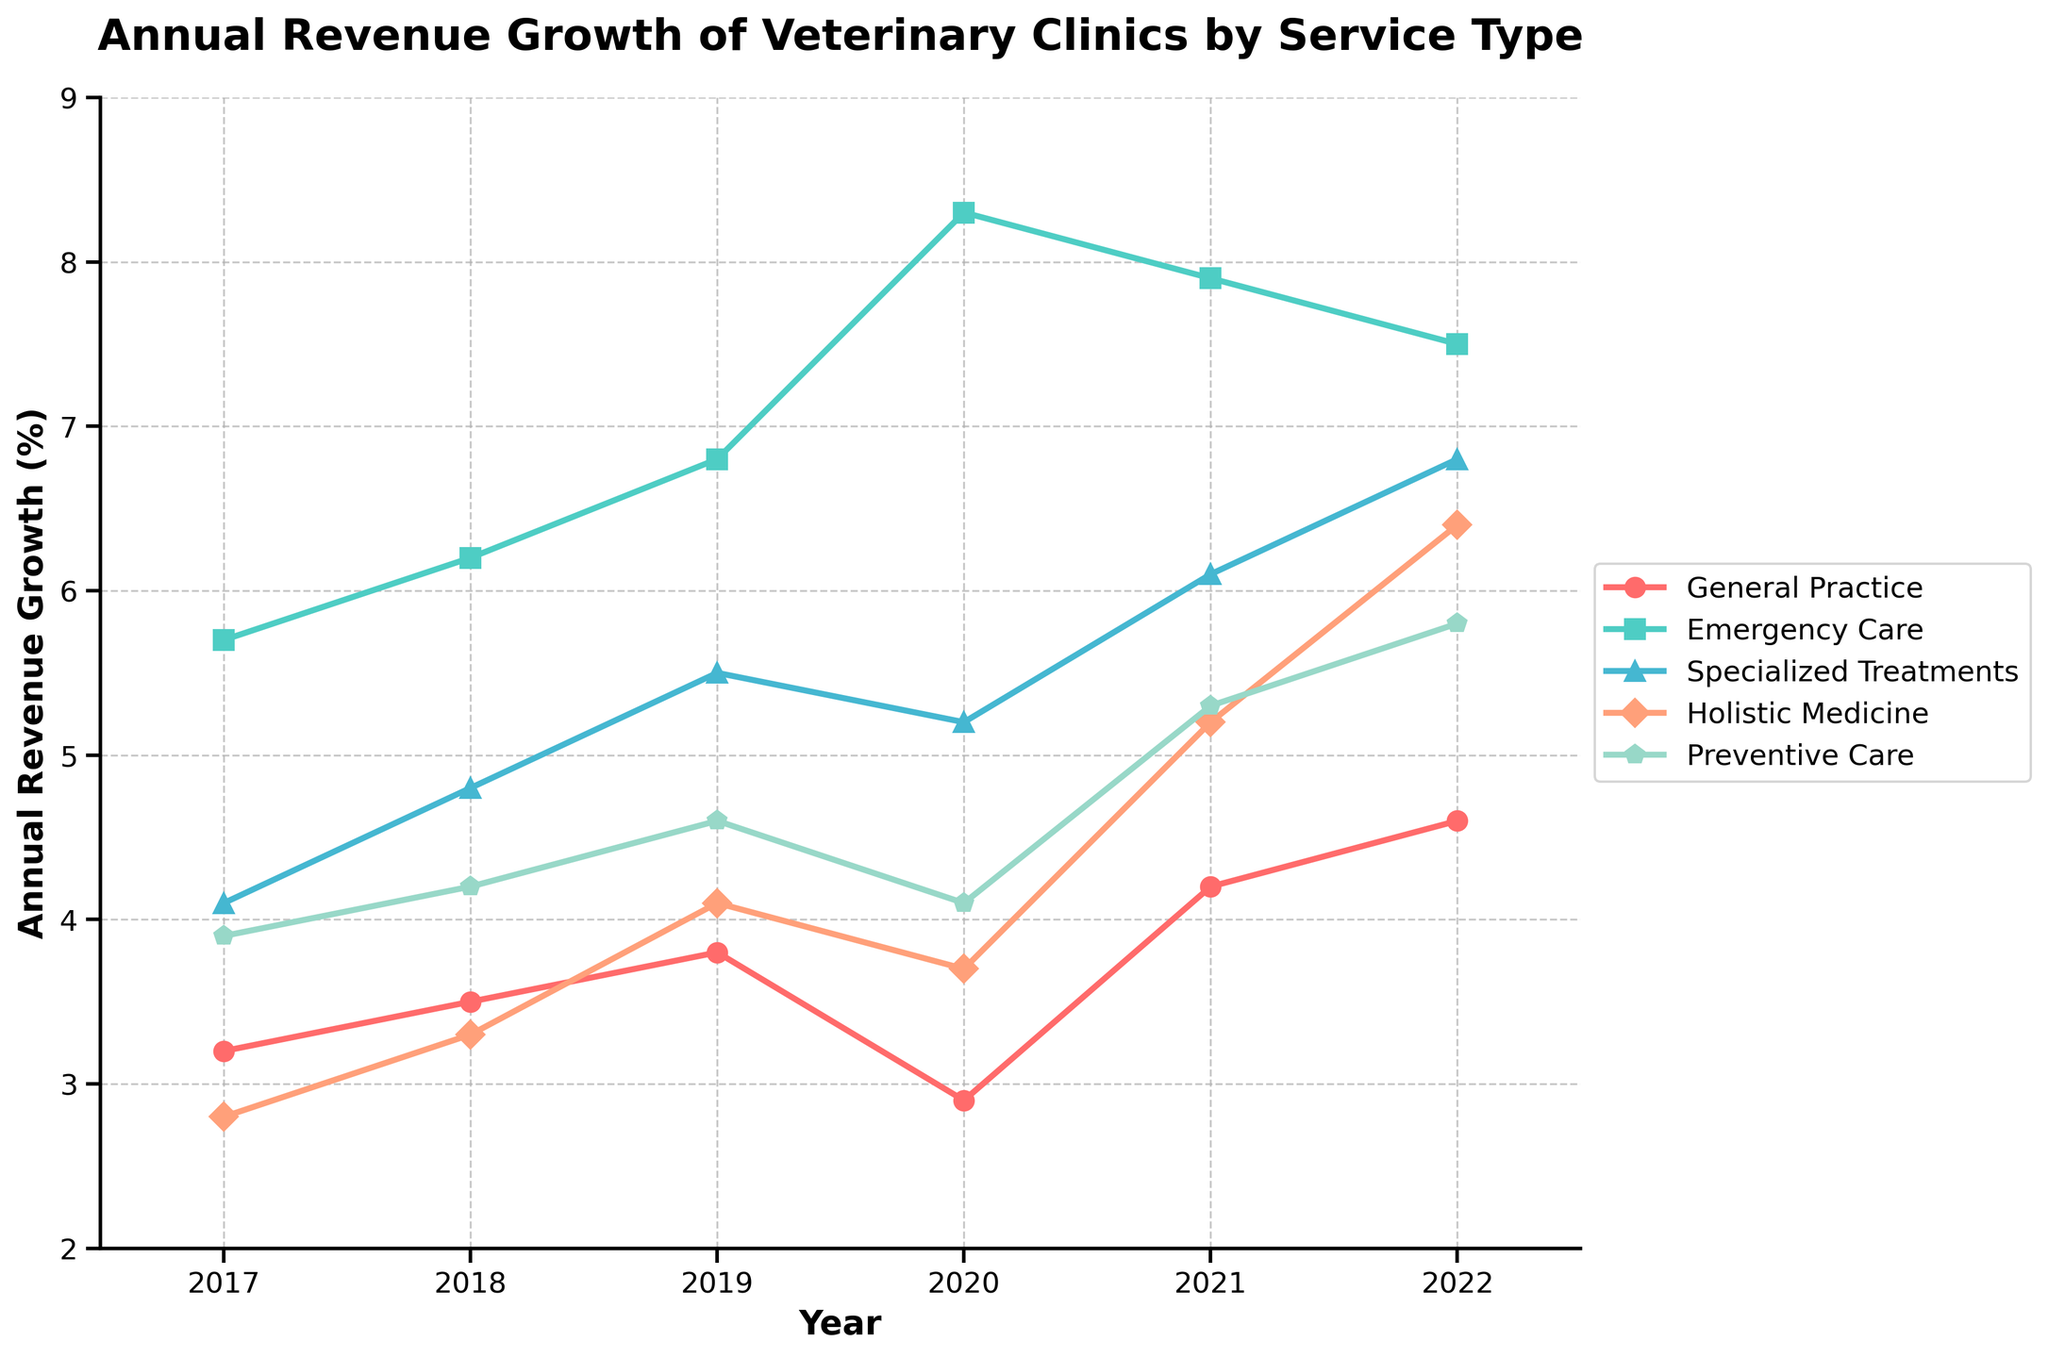What service type had the highest revenue growth in 2020? The highest data point in 2020 corresponds to Emergency Care. By checking the values, Emergency Care has a growth rate of 8.3%, which is the highest among all services for that year.
Answer: Emergency Care Compare the revenue growth in Holistic Medicine between 2019 and 2020. How much did it change? The revenue growth for Holistic Medicine in 2019 was 4.1%. In 2020, it was 3.7%. The change is calculated as 3.7% - 4.1% = -0.4%, indicating a decline.
Answer: -0.4% Which service showed a steady increase in growth rate from 2017 to 2022? By inspecting the pattern of revenue growth across the years, Specialized Treatments showed a consistent increase from 4.1% in 2017 to 6.8% in 2022 without any decline.
Answer: Specialized Treatments What is the average annual revenue growth for Preventive Care from 2017 to 2022? Calculate the sum of revenue growth for Preventive Care across the years and divide by the number of years. (3.9 + 4.2 + 4.6 + 4.1 + 5.3 + 5.8) / 6 = 27.9 / 6 = 4.65%
Answer: 4.65% In which year did General Practice have the lowest revenue growth? By reviewing the annual revenue growth percentages for General Practice, the lowest value is 2.9% in 2020.
Answer: 2020 Which service type had the second-highest growth rate in 2021? In 2021, Emergency Care had the highest growth at 7.9%. The next highest is Specialized Treatments at 6.1%.
Answer: Specialized Treatments How did the growth rate of General Practice change from 2020 to 2021? The growth rate for General Practice increased from 2.9% in 2020 to 4.2% in 2021. The change is calculated as 4.2% - 2.9% = 1.3%.
Answer: 1.3% Between 2018 and 2022, which service had the greatest overall increase in revenue growth? Calculate the difference in revenue growth for each service between 2018 and 2022:
- General Practice: 4.6% - 3.5% = 1.1%
- Emergency Care: 7.5% - 6.2% = 1.3%
- Specialized Treatments: 6.8% - 4.8% = 2.0%
- Holistic Medicine: 6.4% - 3.3% = 3.1%
- Preventive Care: 5.8% - 4.2% = 1.6%
Holistic Medicine shows the greatest increase, at 3.1%.
Answer: Holistic Medicine Which service type had a decline in growth rate for two consecutive years? Emergency Care experienced a decline from 2020 to 2021 (8.3% to 7.9%) and again from 2021 to 2022 (7.9% to 7.5%).
Answer: Emergency Care Among all services, which year marked the largest overall growth for any service? By scanning the highest points across the years, Emergency Care in 2020 has the largest growth rate at 8.3%.
Answer: 2020 